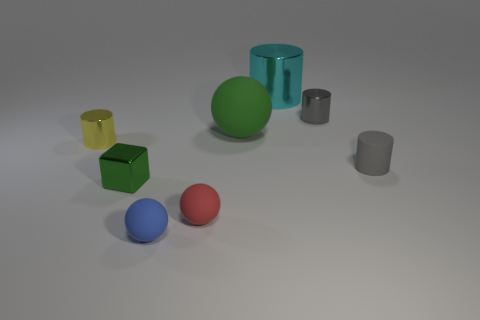Subtract all yellow cylinders. How many cylinders are left? 3 Subtract 2 cylinders. How many cylinders are left? 2 Subtract all blue cylinders. Subtract all green blocks. How many cylinders are left? 4 Add 1 gray things. How many objects exist? 9 Subtract all cubes. How many objects are left? 7 Add 4 cyan objects. How many cyan objects are left? 5 Add 5 small green things. How many small green things exist? 6 Subtract 0 blue blocks. How many objects are left? 8 Subtract all red shiny cubes. Subtract all small matte balls. How many objects are left? 6 